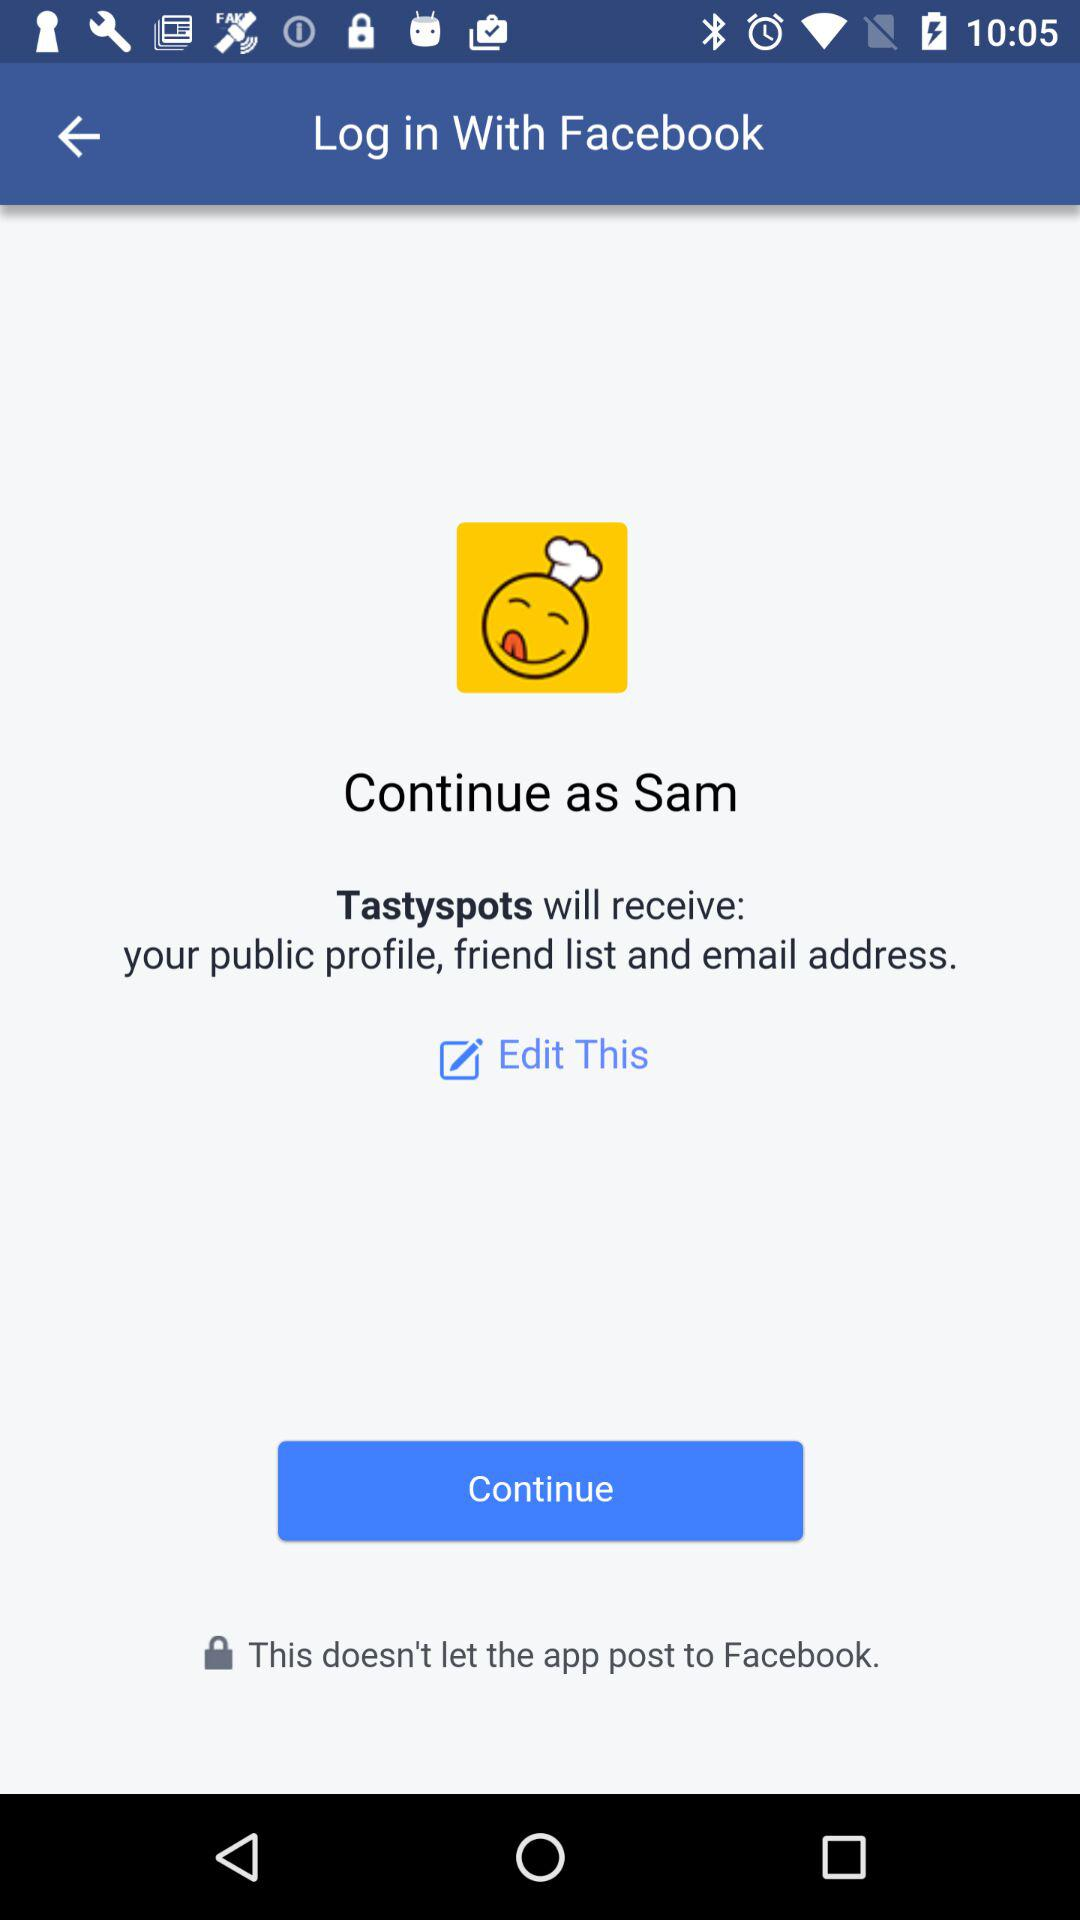How can we log in? You can log in with "Facebook". 